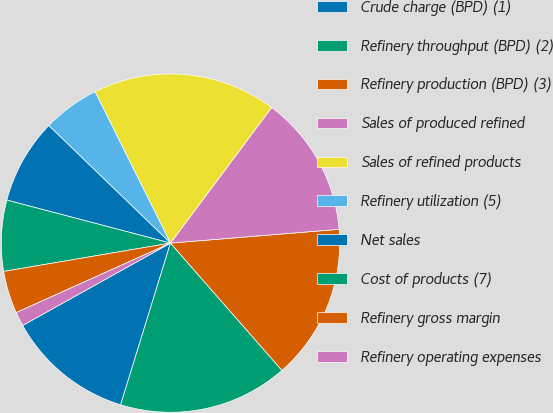Convert chart to OTSL. <chart><loc_0><loc_0><loc_500><loc_500><pie_chart><fcel>Crude charge (BPD) (1)<fcel>Refinery throughput (BPD) (2)<fcel>Refinery production (BPD) (3)<fcel>Sales of produced refined<fcel>Sales of refined products<fcel>Refinery utilization (5)<fcel>Net sales<fcel>Cost of products (7)<fcel>Refinery gross margin<fcel>Refinery operating expenses<nl><fcel>12.15%<fcel>16.21%<fcel>14.85%<fcel>13.5%<fcel>17.56%<fcel>5.42%<fcel>8.13%<fcel>6.77%<fcel>4.06%<fcel>1.35%<nl></chart> 